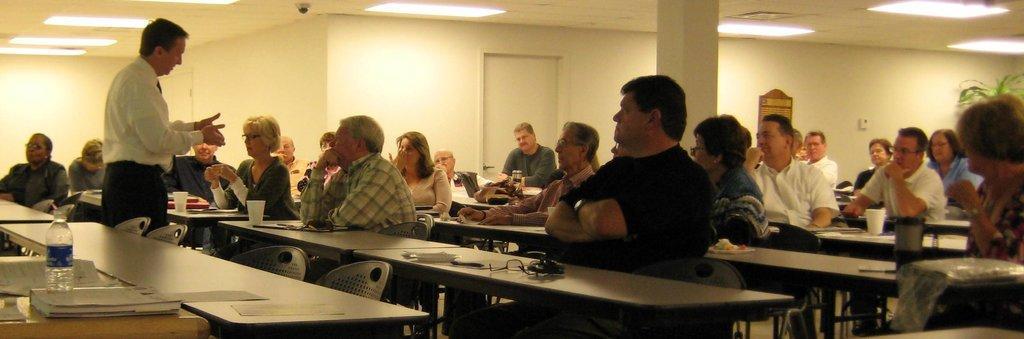Could you give a brief overview of what you see in this image? In this image i can see number of people sitting on chairs in front of a table, On the table i can see few papers and a cup, i can see a person wearing white shirt and black jeans standing. In the background i can see a wall, a door, the ceiling and the light. 